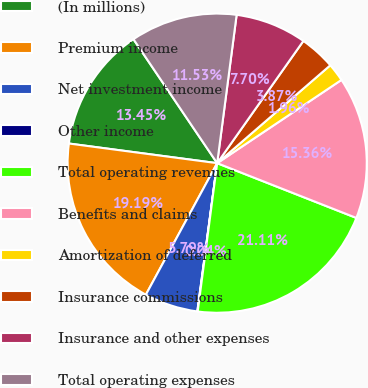<chart> <loc_0><loc_0><loc_500><loc_500><pie_chart><fcel>(In millions)<fcel>Premium income<fcel>Net investment income<fcel>Other income<fcel>Total operating revenues<fcel>Benefits and claims<fcel>Amortization of deferred<fcel>Insurance commissions<fcel>Insurance and other expenses<fcel>Total operating expenses<nl><fcel>13.45%<fcel>19.19%<fcel>5.79%<fcel>0.04%<fcel>21.11%<fcel>15.36%<fcel>1.96%<fcel>3.87%<fcel>7.7%<fcel>11.53%<nl></chart> 